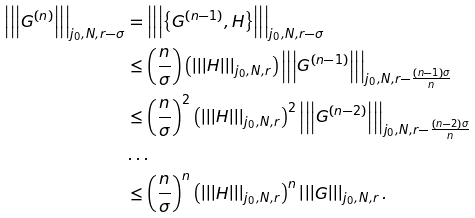<formula> <loc_0><loc_0><loc_500><loc_500>\left | \left | \left | G ^ { ( n ) } \right | \right | \right | _ { j _ { 0 } , N , r - \sigma } & = \left | \left | \left | \left \{ G ^ { ( n - 1 ) } , H \right \} \right | \right | \right | _ { j _ { 0 } , N , r - \sigma } \\ & \leq \left ( \frac { n } { \sigma } \right ) \left ( \left | \left | \left | H \right | \right | \right | _ { j _ { 0 } , N , r } \right ) \left | \left | \left | G ^ { ( n - 1 ) } \right | \right | \right | _ { j _ { 0 } , N , r - \frac { ( n - 1 ) \sigma } { n } } \\ & \leq \left ( \frac { n } { \sigma } \right ) ^ { 2 } \left ( \left | \left | \left | H \right | \right | \right | _ { j _ { 0 } , N , r } \right ) ^ { 2 } \left | \left | \left | G ^ { ( n - 2 ) } \right | \right | \right | _ { j _ { 0 } , N , r - \frac { ( n - 2 ) \sigma } { n } } \\ & \dots \\ & \leq \left ( \frac { n } { \sigma } \right ) ^ { n } \left ( \left | \left | \left | H \right | \right | \right | _ { j _ { 0 } , N , r } \right ) ^ { n } \left | \left | \left | G \right | \right | \right | _ { j _ { 0 } , N , r } .</formula> 